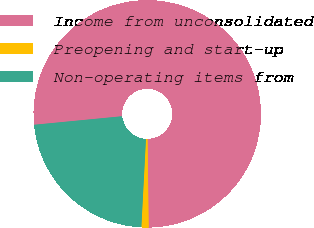Convert chart. <chart><loc_0><loc_0><loc_500><loc_500><pie_chart><fcel>Income from unconsolidated<fcel>Preopening and start-up<fcel>Non-operating items from<nl><fcel>76.34%<fcel>1.03%<fcel>22.63%<nl></chart> 